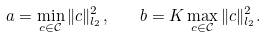Convert formula to latex. <formula><loc_0><loc_0><loc_500><loc_500>a = \min _ { c \in \mathcal { C } } \| c \| ^ { 2 } _ { l _ { 2 } } , \quad b = K \max _ { c \in \mathcal { C } } \| c \| ^ { 2 } _ { l _ { 2 } } .</formula> 